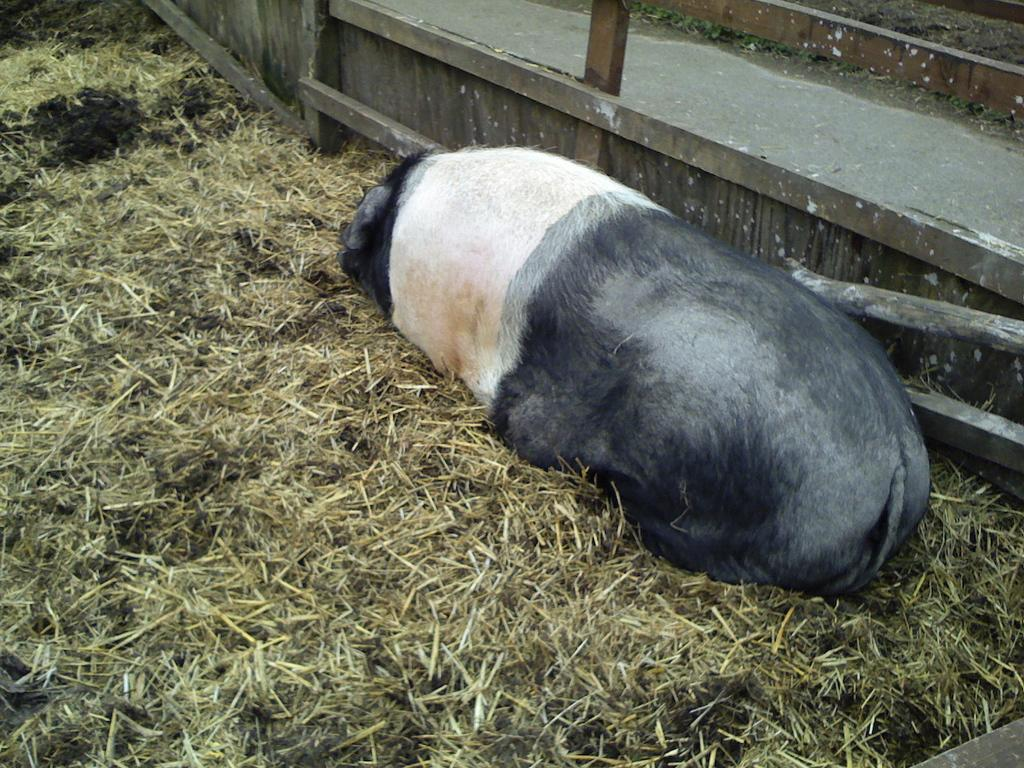What type of animal is in the image? There is an animal in the image, but the specific type is not mentioned in the facts. What is on the ground in the image? There is dried grass on the ground in the image. What type of barrier is present in the image? There is wooden fencing in the image. What type of path can be seen in the image? There is a small road in the image. What type of flock is the animal leading in the image? There is no flock present in the image, and the animal is not leading any group. 